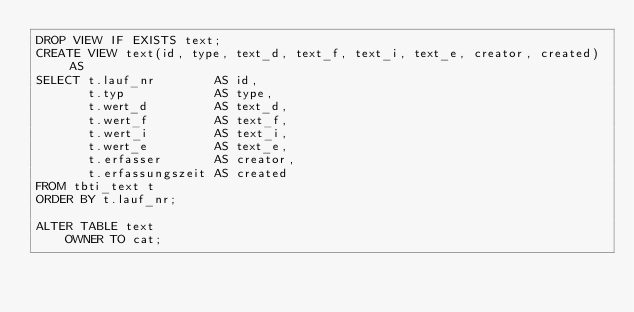<code> <loc_0><loc_0><loc_500><loc_500><_SQL_>DROP VIEW IF EXISTS text;
CREATE VIEW text(id, type, text_d, text_f, text_i, text_e, creator, created) AS
SELECT t.lauf_nr        AS id,
       t.typ            AS type,
       t.wert_d         AS text_d,
       t.wert_f         AS text_f,
       t.wert_i         AS text_i,
       t.wert_e         AS text_e,
       t.erfasser       AS creator,
       t.erfassungszeit AS created
FROM tbti_text t
ORDER BY t.lauf_nr;

ALTER TABLE text
    OWNER TO cat;

</code> 